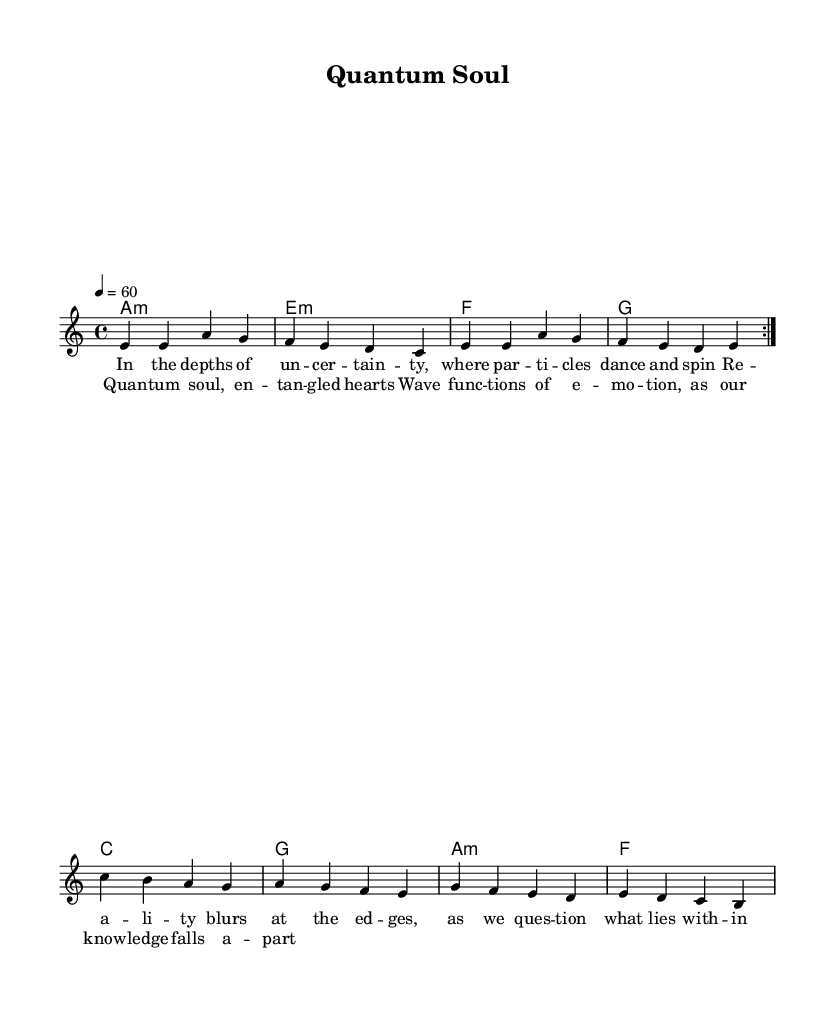What is the key signature of this music? The key signature is A minor, which has no sharps or flats. This is indicated by the presence of only A minor chords in the harmonic section of the music.
Answer: A minor What is the time signature of this piece? The time signature is 4/4, which means there are four beats in each measure and a quarter note gets one beat. This can be identified at the beginning of the sheet music where the time signature is displayed.
Answer: 4/4 What is the tempo marking of this piece? The tempo marking indicates that the piece should be played at a speed of 60 beats per minute. This is specified in the tempo instruction at the beginning of the score.
Answer: 60 How many phrases are there in the melody section? The melody section has two phrases, indicated by the repeat sign. A repeat sign means the section is played twice and constitutes two distinct phrases in the music.
Answer: 2 Which lyrical theme is embraced in the chorus? The lyrical theme in the chorus reflects emotional entanglement and knowledge fragmentation similar to quantum mechanics concepts, as suggested by the words used in the lyrics.
Answer: Quantum entanglement What are the primary emotional themes expressed in the verse? The verse expresses uncertainty and philosophical questioning about reality, as the lyrics discuss the dance of particles and the blurring of reality. These themes echo deeper connections to the philosophical implications of quantum mechanics.
Answer: Uncertainty What chord follows the first repeat in the melody? The chord following the first repeat in the melody is an A minor chord, as it corresponds to the first chord listed in the harmonic section after the repeat sign.
Answer: A minor 